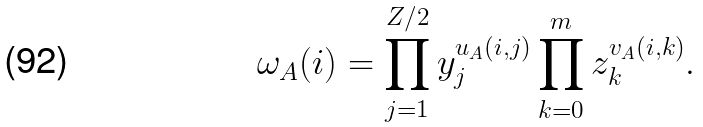Convert formula to latex. <formula><loc_0><loc_0><loc_500><loc_500>\omega _ { A } ( i ) = \prod _ { j = 1 } ^ { Z / 2 } y _ { j } ^ { u _ { A } ( i , j ) } \prod _ { k = 0 } ^ { m } z _ { k } ^ { v _ { A } ( i , k ) } .</formula> 